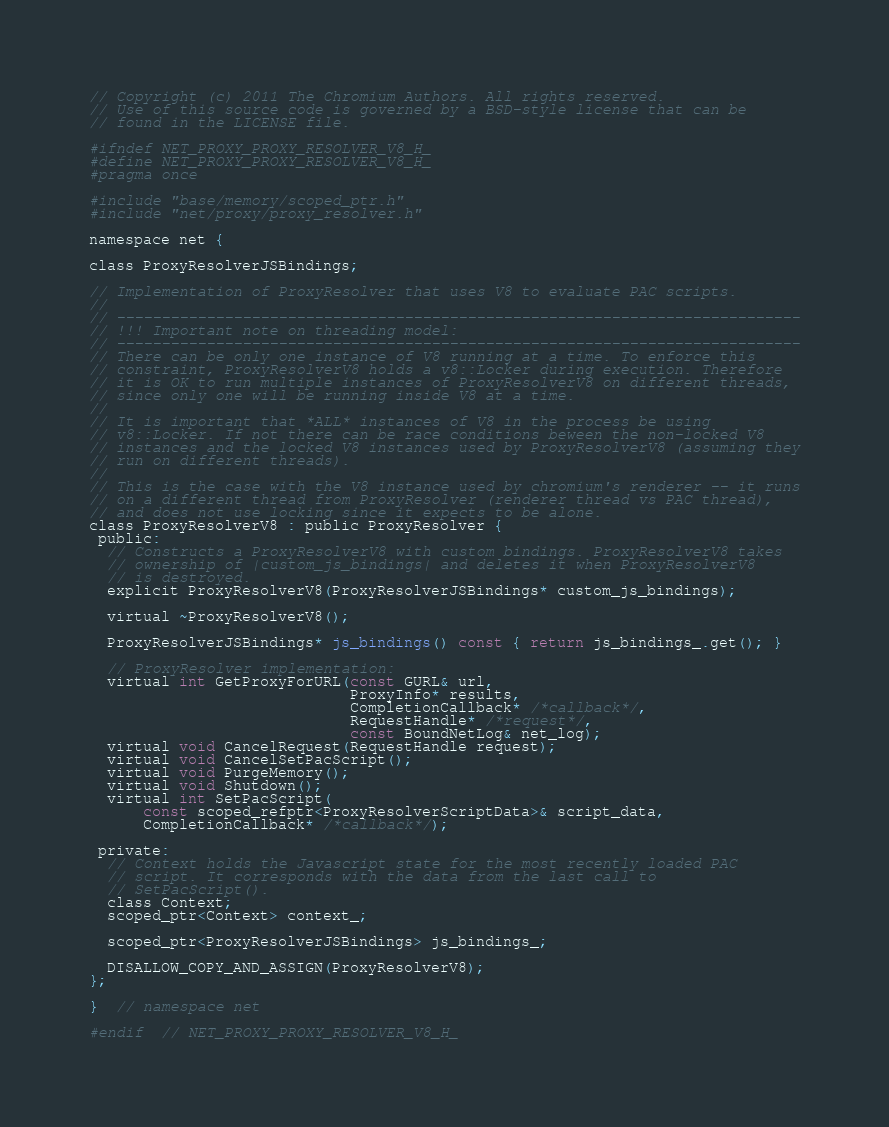<code> <loc_0><loc_0><loc_500><loc_500><_C_>// Copyright (c) 2011 The Chromium Authors. All rights reserved.
// Use of this source code is governed by a BSD-style license that can be
// found in the LICENSE file.

#ifndef NET_PROXY_PROXY_RESOLVER_V8_H_
#define NET_PROXY_PROXY_RESOLVER_V8_H_
#pragma once

#include "base/memory/scoped_ptr.h"
#include "net/proxy/proxy_resolver.h"

namespace net {

class ProxyResolverJSBindings;

// Implementation of ProxyResolver that uses V8 to evaluate PAC scripts.
//
// ----------------------------------------------------------------------------
// !!! Important note on threading model:
// ----------------------------------------------------------------------------
// There can be only one instance of V8 running at a time. To enforce this
// constraint, ProxyResolverV8 holds a v8::Locker during execution. Therefore
// it is OK to run multiple instances of ProxyResolverV8 on different threads,
// since only one will be running inside V8 at a time.
//
// It is important that *ALL* instances of V8 in the process be using
// v8::Locker. If not there can be race conditions beween the non-locked V8
// instances and the locked V8 instances used by ProxyResolverV8 (assuming they
// run on different threads).
//
// This is the case with the V8 instance used by chromium's renderer -- it runs
// on a different thread from ProxyResolver (renderer thread vs PAC thread),
// and does not use locking since it expects to be alone.
class ProxyResolverV8 : public ProxyResolver {
 public:
  // Constructs a ProxyResolverV8 with custom bindings. ProxyResolverV8 takes
  // ownership of |custom_js_bindings| and deletes it when ProxyResolverV8
  // is destroyed.
  explicit ProxyResolverV8(ProxyResolverJSBindings* custom_js_bindings);

  virtual ~ProxyResolverV8();

  ProxyResolverJSBindings* js_bindings() const { return js_bindings_.get(); }

  // ProxyResolver implementation:
  virtual int GetProxyForURL(const GURL& url,
                             ProxyInfo* results,
                             CompletionCallback* /*callback*/,
                             RequestHandle* /*request*/,
                             const BoundNetLog& net_log);
  virtual void CancelRequest(RequestHandle request);
  virtual void CancelSetPacScript();
  virtual void PurgeMemory();
  virtual void Shutdown();
  virtual int SetPacScript(
      const scoped_refptr<ProxyResolverScriptData>& script_data,
      CompletionCallback* /*callback*/);

 private:
  // Context holds the Javascript state for the most recently loaded PAC
  // script. It corresponds with the data from the last call to
  // SetPacScript().
  class Context;
  scoped_ptr<Context> context_;

  scoped_ptr<ProxyResolverJSBindings> js_bindings_;

  DISALLOW_COPY_AND_ASSIGN(ProxyResolverV8);
};

}  // namespace net

#endif  // NET_PROXY_PROXY_RESOLVER_V8_H_
</code> 